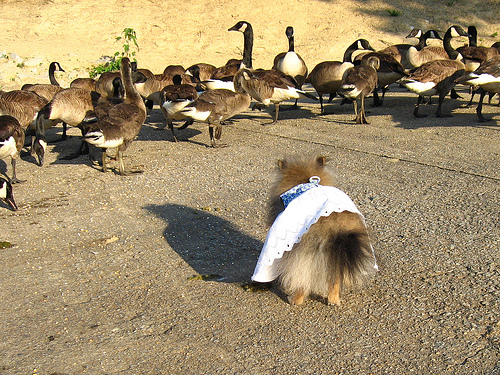<image>
Can you confirm if the dress is on the dog? Yes. Looking at the image, I can see the dress is positioned on top of the dog, with the dog providing support. Is the dog on the duck? No. The dog is not positioned on the duck. They may be near each other, but the dog is not supported by or resting on top of the duck. Where is the dog in relation to the goose? Is it under the goose? No. The dog is not positioned under the goose. The vertical relationship between these objects is different. Where is the dog in relation to the goose? Is it under the goose? No. The dog is not positioned under the goose. The vertical relationship between these objects is different. 